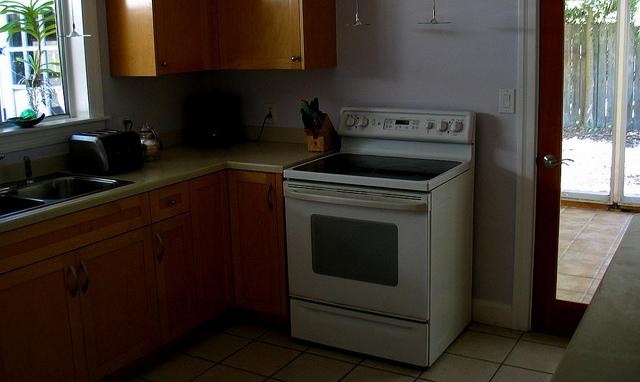What color is the cabinet?
Be succinct. Brown. What color is the oven?
Short answer required. White. Is the back door open?
Quick response, please. No. 